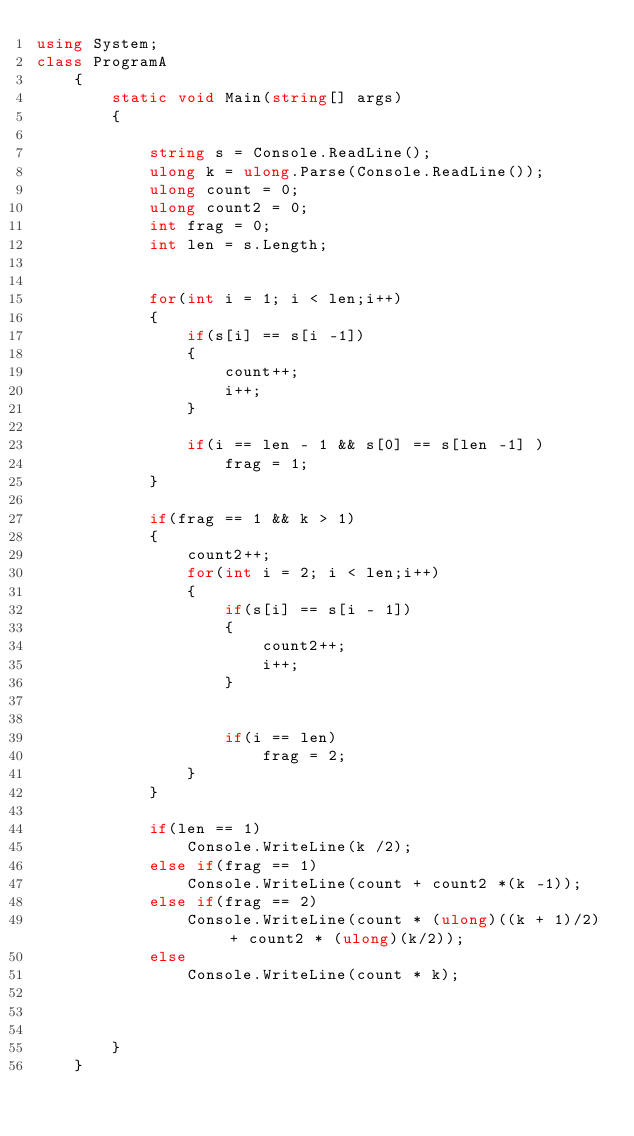<code> <loc_0><loc_0><loc_500><loc_500><_C#_>using System;
class ProgramA
    {
        static void Main(string[] args)
        {
            
            string s = Console.ReadLine();
            ulong k = ulong.Parse(Console.ReadLine());
            ulong count = 0;
            ulong count2 = 0;
            int frag = 0;
            int len = s.Length;
          

            for(int i = 1; i < len;i++)
            {
                if(s[i] == s[i -1])
                {
                    count++;
                    i++;
                }
                
                if(i == len - 1 && s[0] == s[len -1] )
                    frag = 1;
            }

            if(frag == 1 && k > 1)
            {
                count2++;
                for(int i = 2; i < len;i++)
                {
                    if(s[i] == s[i - 1])
                    {
                        count2++;
                        i++;
                    }
                    
                    
                    if(i == len)
                        frag = 2;
                }
            }
            
            if(len == 1)
                Console.WriteLine(k /2);
            else if(frag == 1)
                Console.WriteLine(count + count2 *(k -1));
            else if(frag == 2)
                Console.WriteLine(count * (ulong)((k + 1)/2) + count2 * (ulong)(k/2));
            else
                Console.WriteLine(count * k);
                

            
        }
    }</code> 